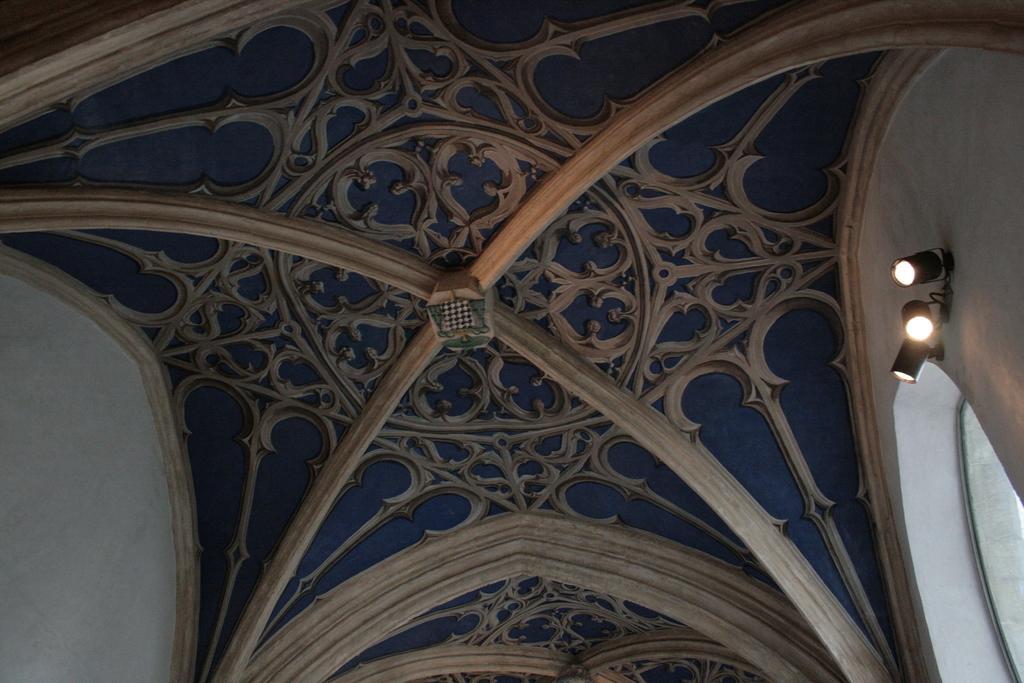How would you summarize this image in a sentence or two? In this picture we can see three lights, window and a design roof. 